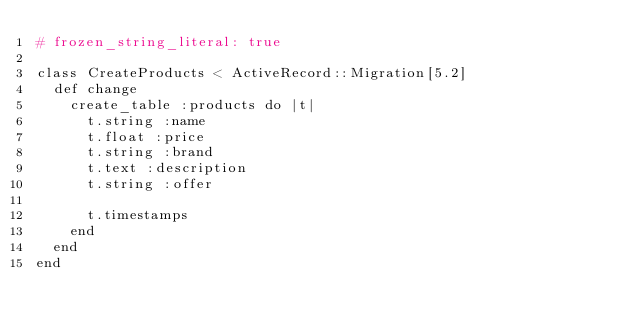<code> <loc_0><loc_0><loc_500><loc_500><_Ruby_># frozen_string_literal: true

class CreateProducts < ActiveRecord::Migration[5.2]
  def change
    create_table :products do |t|
      t.string :name
      t.float :price
      t.string :brand
      t.text :description
      t.string :offer

      t.timestamps
    end
  end
end
</code> 